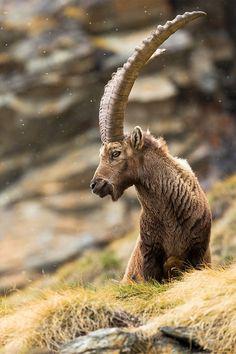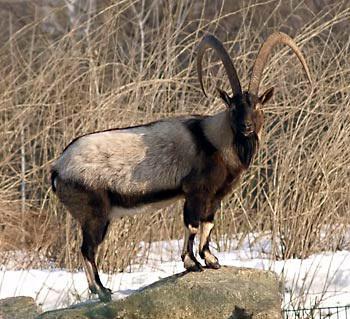The first image is the image on the left, the second image is the image on the right. Evaluate the accuracy of this statement regarding the images: "Each image contains just one horned animal, and one image shows an animal reclining on a rock, with large boulders behind it.". Is it true? Answer yes or no. No. 